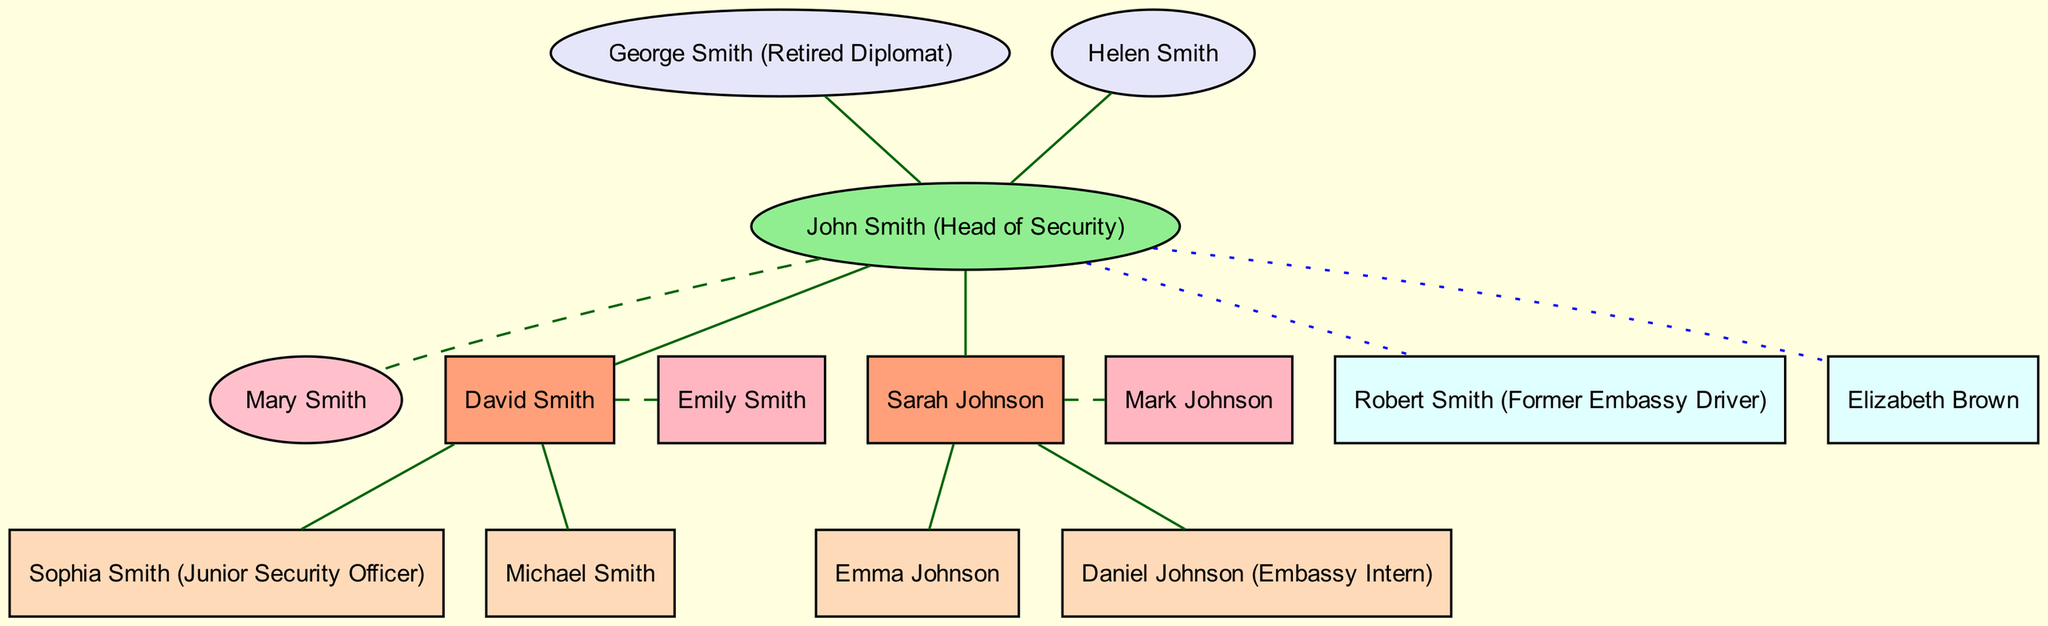What is the name of the head of security? The root of the family tree is John Smith, designated as the Head of Security.
Answer: John Smith How many children does John Smith have? The diagram indicates two children listed under John Smith: David Smith and Sarah Johnson.
Answer: 2 Who is married to David Smith? The diagram connects David Smith to Emily Smith through a dashed edge, indicating their marriage.
Answer: Emily Smith What is the occupation of Daniel Johnson? The diagram specifies that Daniel Johnson is an Embassy Intern labeled within parentheses next to his name.
Answer: Embassy Intern Name one of John Smith's siblings. The diagram lists Robert Smith and Elizabeth Brown as siblings of John Smith.
Answer: Robert Smith How many grandchildren does David Smith have? Looking at David Smith’s children, Sophia Smith and Michael Smith, we find that he has two grandchildren listed.
Answer: 2 What is the relationship between George Smith and John Smith? George Smith is connected to John Smith with a solid line indicating that George is John’s father, as labeled in the diagram.
Answer: Father Who is the spouse of Sarah Johnson? The diagram shows a marriage connection marked by a dashed line from Sarah Johnson to Mark Johnson, indicating their marriage relationship.
Answer: Mark Johnson What color represents the head of security in the diagram? The head of security, John Smith, is represented by a light green ellipse node in the diagram.
Answer: Light green 